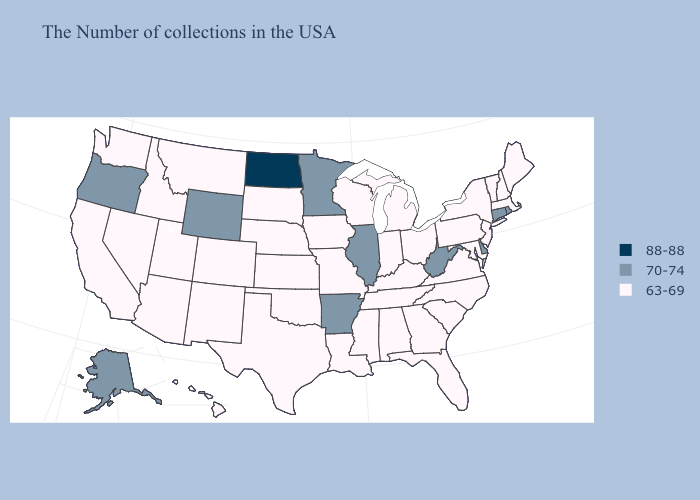Does Illinois have a lower value than Delaware?
Be succinct. No. What is the lowest value in the Northeast?
Give a very brief answer. 63-69. Name the states that have a value in the range 88-88?
Short answer required. North Dakota. Name the states that have a value in the range 88-88?
Keep it brief. North Dakota. Does the first symbol in the legend represent the smallest category?
Keep it brief. No. What is the value of Oklahoma?
Short answer required. 63-69. Name the states that have a value in the range 63-69?
Short answer required. Maine, Massachusetts, New Hampshire, Vermont, New York, New Jersey, Maryland, Pennsylvania, Virginia, North Carolina, South Carolina, Ohio, Florida, Georgia, Michigan, Kentucky, Indiana, Alabama, Tennessee, Wisconsin, Mississippi, Louisiana, Missouri, Iowa, Kansas, Nebraska, Oklahoma, Texas, South Dakota, Colorado, New Mexico, Utah, Montana, Arizona, Idaho, Nevada, California, Washington, Hawaii. Name the states that have a value in the range 63-69?
Keep it brief. Maine, Massachusetts, New Hampshire, Vermont, New York, New Jersey, Maryland, Pennsylvania, Virginia, North Carolina, South Carolina, Ohio, Florida, Georgia, Michigan, Kentucky, Indiana, Alabama, Tennessee, Wisconsin, Mississippi, Louisiana, Missouri, Iowa, Kansas, Nebraska, Oklahoma, Texas, South Dakota, Colorado, New Mexico, Utah, Montana, Arizona, Idaho, Nevada, California, Washington, Hawaii. Does the first symbol in the legend represent the smallest category?
Write a very short answer. No. What is the highest value in states that border Delaware?
Concise answer only. 63-69. Does Connecticut have the lowest value in the Northeast?
Be succinct. No. Which states have the highest value in the USA?
Concise answer only. North Dakota. What is the lowest value in the USA?
Answer briefly. 63-69. Name the states that have a value in the range 88-88?
Answer briefly. North Dakota. 